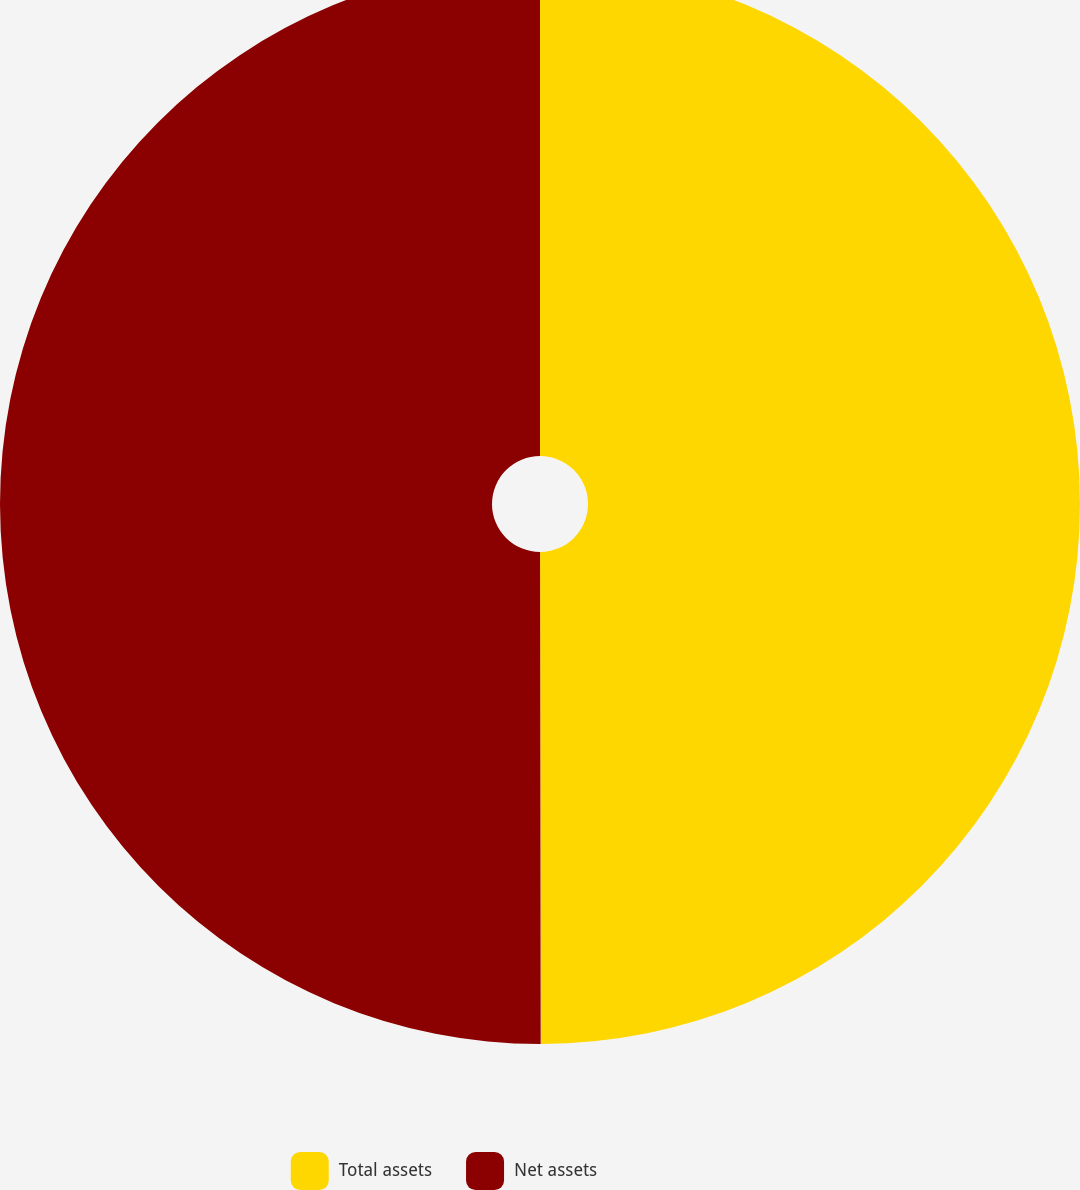<chart> <loc_0><loc_0><loc_500><loc_500><pie_chart><fcel>Total assets<fcel>Net assets<nl><fcel>49.98%<fcel>50.02%<nl></chart> 